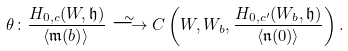Convert formula to latex. <formula><loc_0><loc_0><loc_500><loc_500>\theta \colon \frac { H _ { 0 , c } ( W , \mathfrak { h } ) } { \langle \mathfrak { m } ( b ) \rangle } \stackrel { \sim } { \longrightarrow } C \left ( W , W _ { b } , \frac { H _ { 0 , c ^ { \prime } } ( W _ { b } , \mathfrak { h } ) } { \langle \mathfrak { n } ( 0 ) \rangle } \right ) .</formula> 